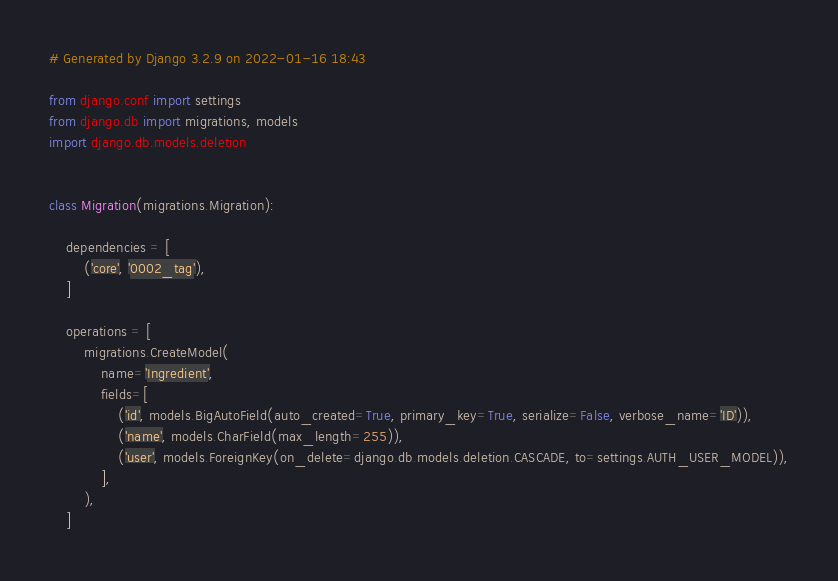Convert code to text. <code><loc_0><loc_0><loc_500><loc_500><_Python_># Generated by Django 3.2.9 on 2022-01-16 18:43

from django.conf import settings
from django.db import migrations, models
import django.db.models.deletion


class Migration(migrations.Migration):

    dependencies = [
        ('core', '0002_tag'),
    ]

    operations = [
        migrations.CreateModel(
            name='Ingredient',
            fields=[
                ('id', models.BigAutoField(auto_created=True, primary_key=True, serialize=False, verbose_name='ID')),
                ('name', models.CharField(max_length=255)),
                ('user', models.ForeignKey(on_delete=django.db.models.deletion.CASCADE, to=settings.AUTH_USER_MODEL)),
            ],
        ),
    ]
</code> 